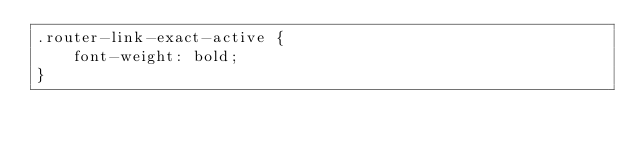<code> <loc_0><loc_0><loc_500><loc_500><_CSS_>.router-link-exact-active {
    font-weight: bold;
}</code> 